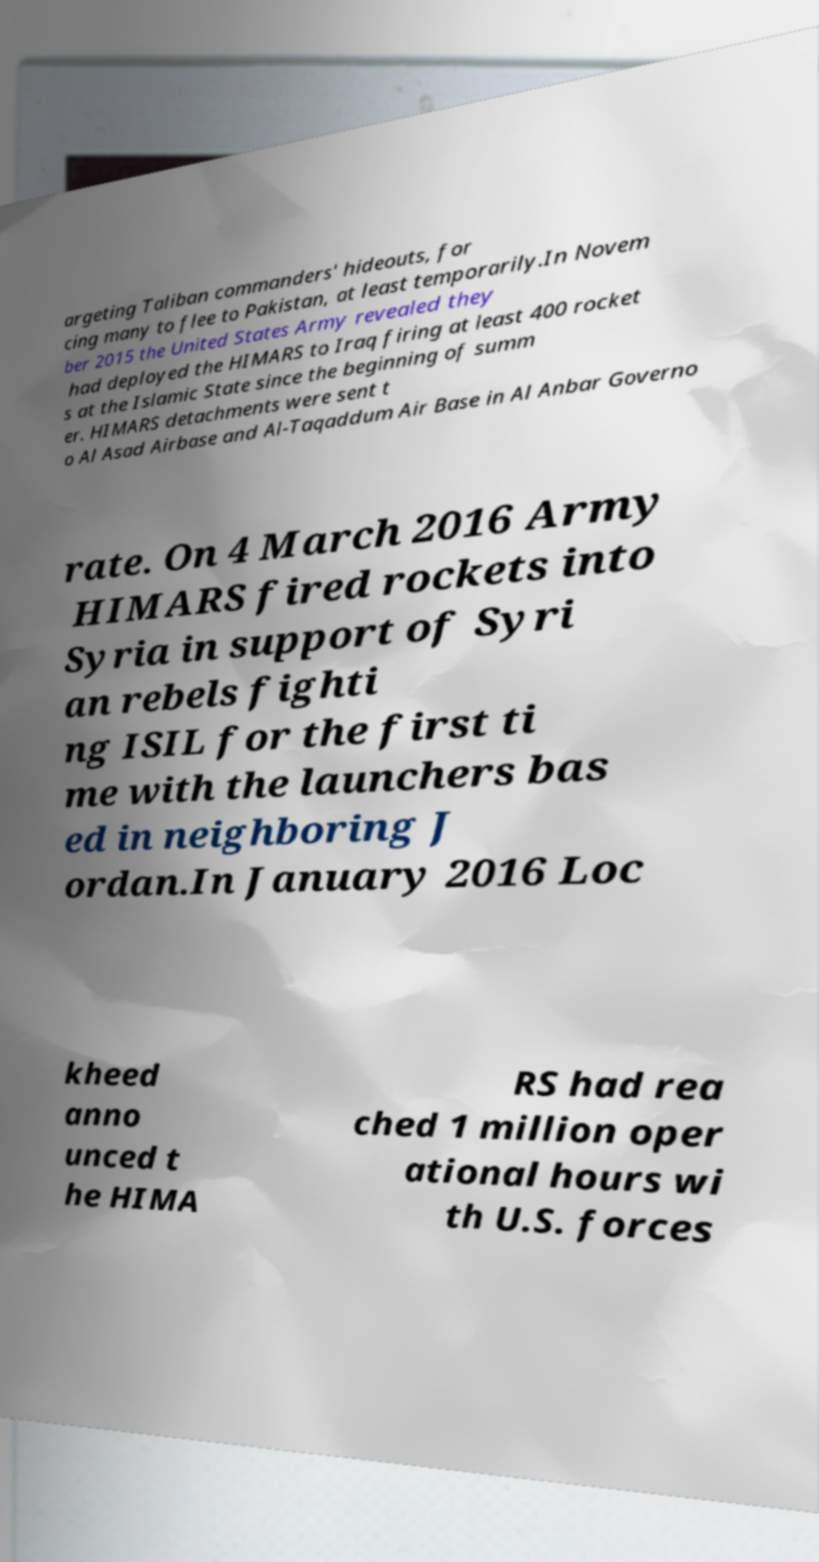Could you extract and type out the text from this image? argeting Taliban commanders' hideouts, for cing many to flee to Pakistan, at least temporarily.In Novem ber 2015 the United States Army revealed they had deployed the HIMARS to Iraq firing at least 400 rocket s at the Islamic State since the beginning of summ er. HIMARS detachments were sent t o Al Asad Airbase and Al-Taqaddum Air Base in Al Anbar Governo rate. On 4 March 2016 Army HIMARS fired rockets into Syria in support of Syri an rebels fighti ng ISIL for the first ti me with the launchers bas ed in neighboring J ordan.In January 2016 Loc kheed anno unced t he HIMA RS had rea ched 1 million oper ational hours wi th U.S. forces 